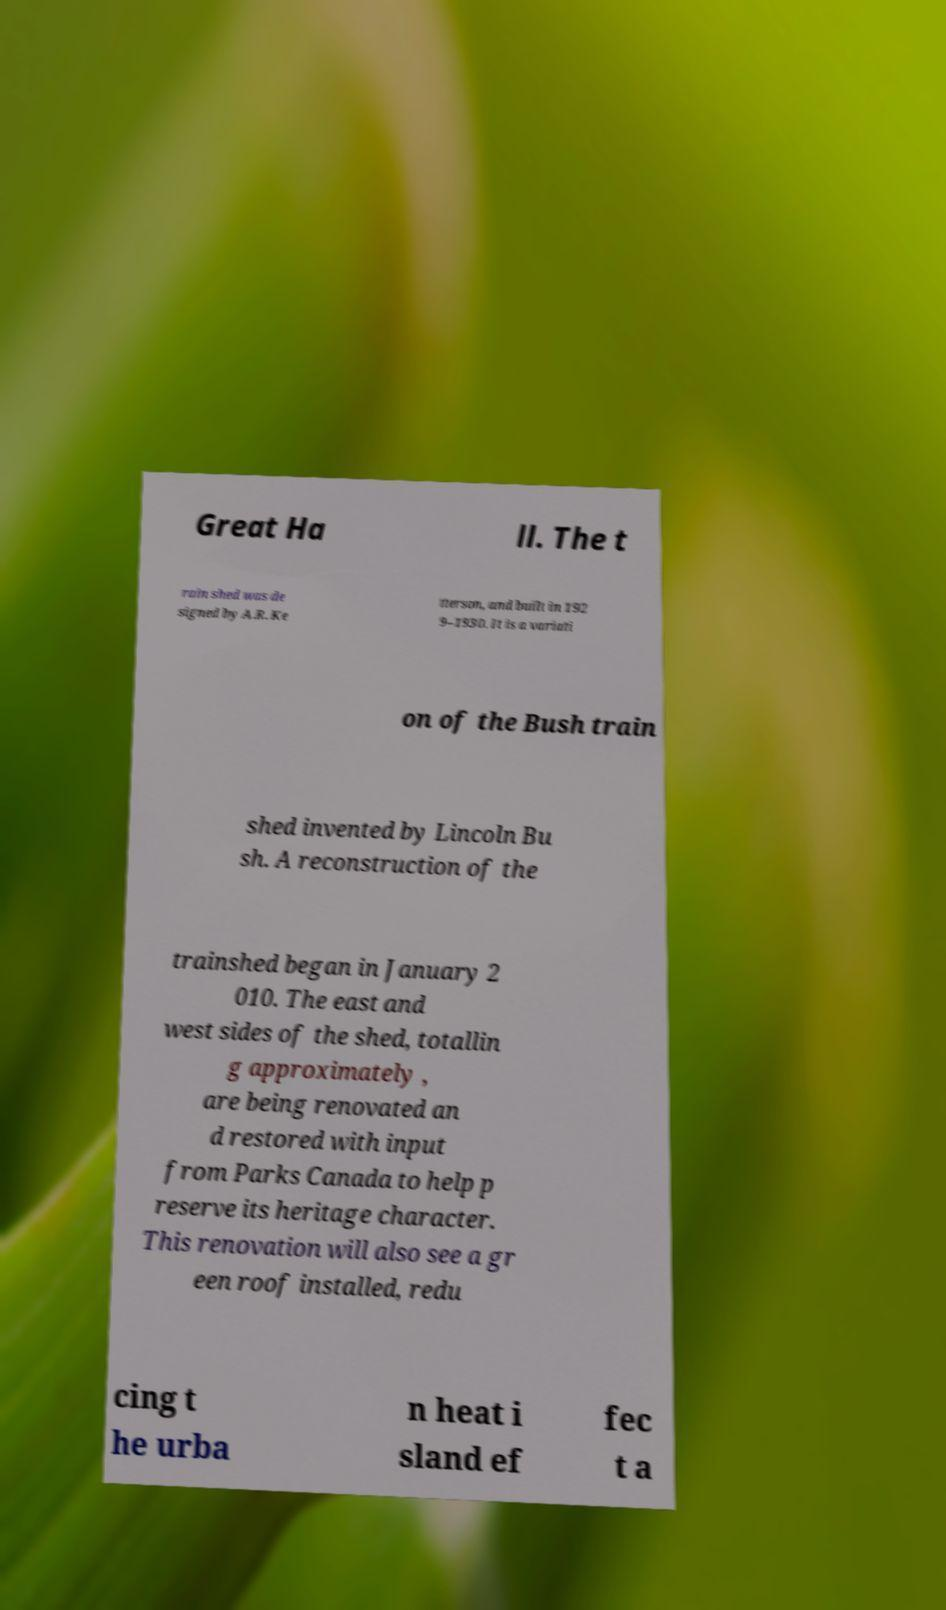Please read and relay the text visible in this image. What does it say? Great Ha ll. The t rain shed was de signed by A.R. Ke tterson, and built in 192 9–1930. It is a variati on of the Bush train shed invented by Lincoln Bu sh. A reconstruction of the trainshed began in January 2 010. The east and west sides of the shed, totallin g approximately , are being renovated an d restored with input from Parks Canada to help p reserve its heritage character. This renovation will also see a gr een roof installed, redu cing t he urba n heat i sland ef fec t a 